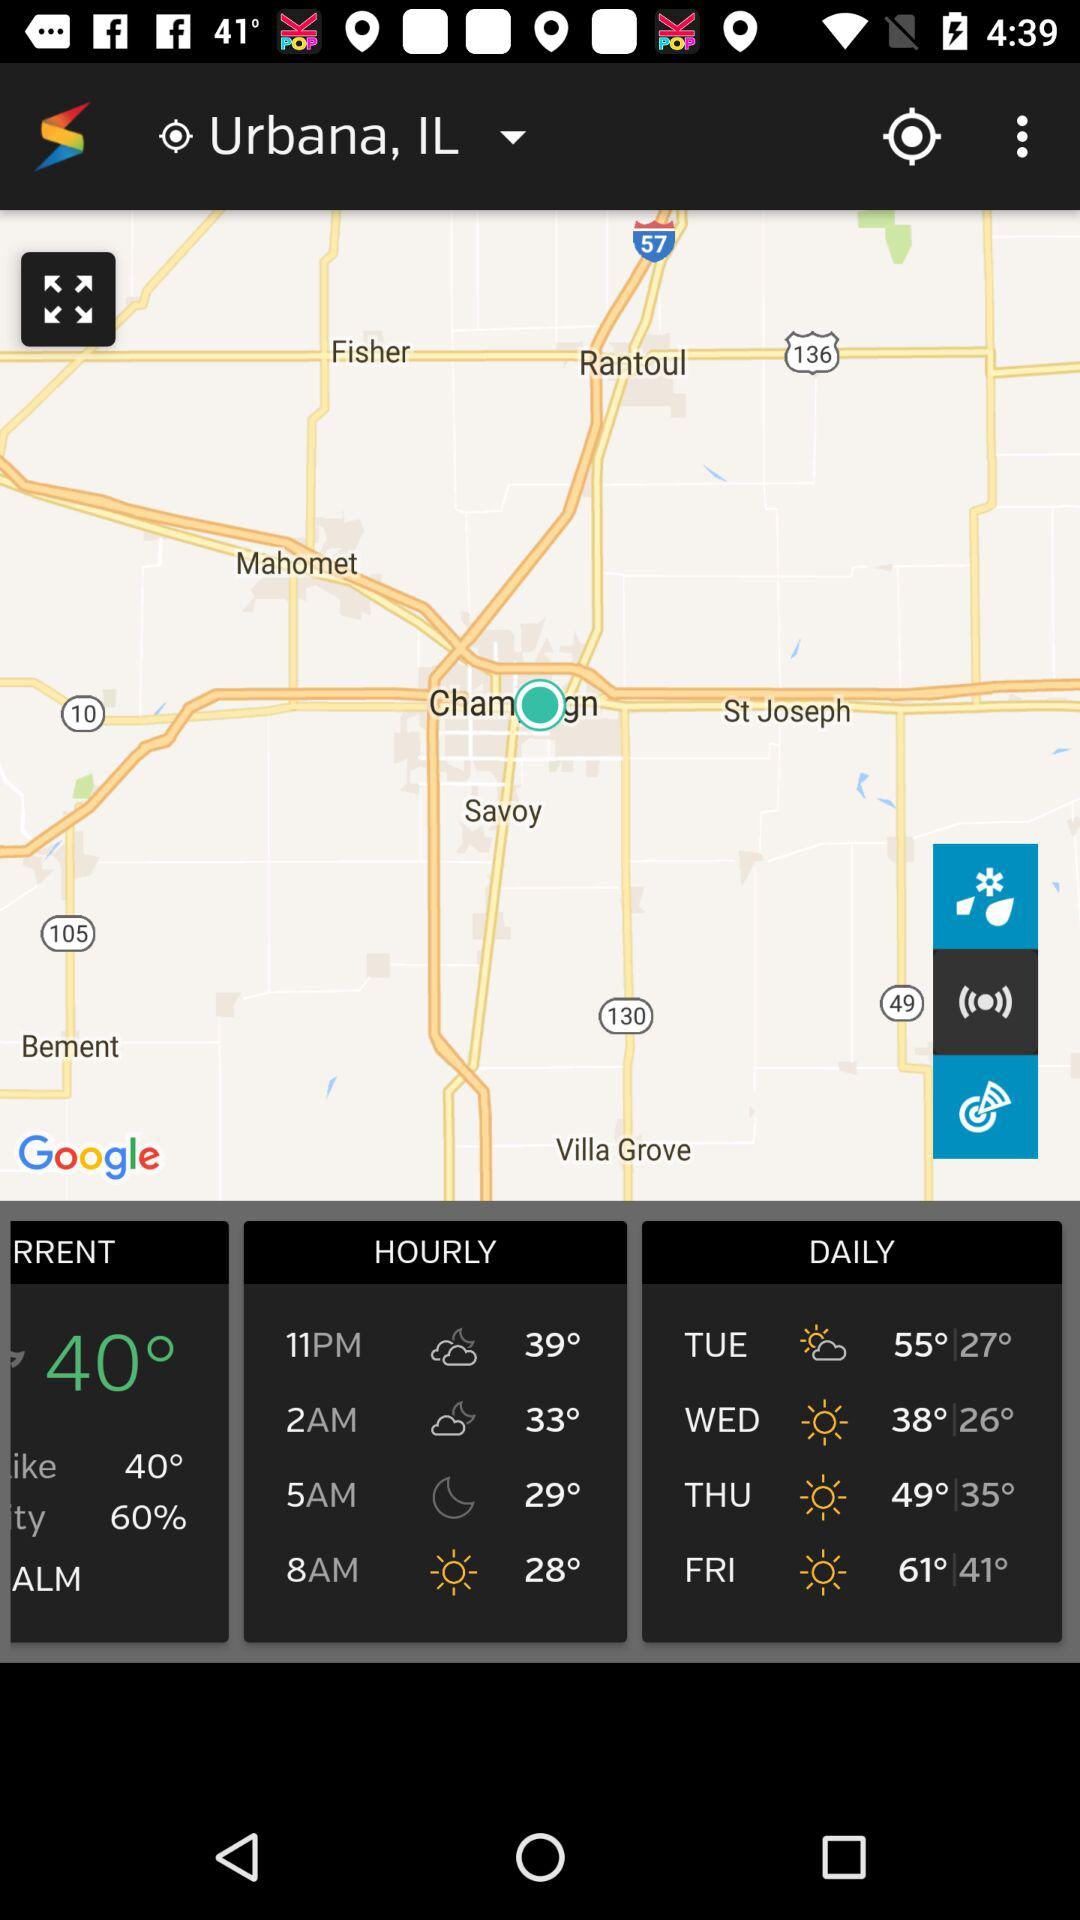What is the temperature at 2 AM? The temperature at 2 AM is 33°. 